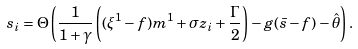Convert formula to latex. <formula><loc_0><loc_0><loc_500><loc_500>s _ { i } = \Theta \left ( \frac { 1 } { 1 + \gamma } \left ( ( \xi ^ { 1 } - f ) m ^ { 1 } + \sigma z _ { i } + \frac { \Gamma } { 2 } \right ) - g ( \bar { s } - f ) - \hat { \theta } \right ) .</formula> 